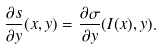<formula> <loc_0><loc_0><loc_500><loc_500>\frac { \partial s } { \partial y } ( x , y ) = \frac { \partial \sigma } { \partial y } ( I ( x ) , y ) .</formula> 